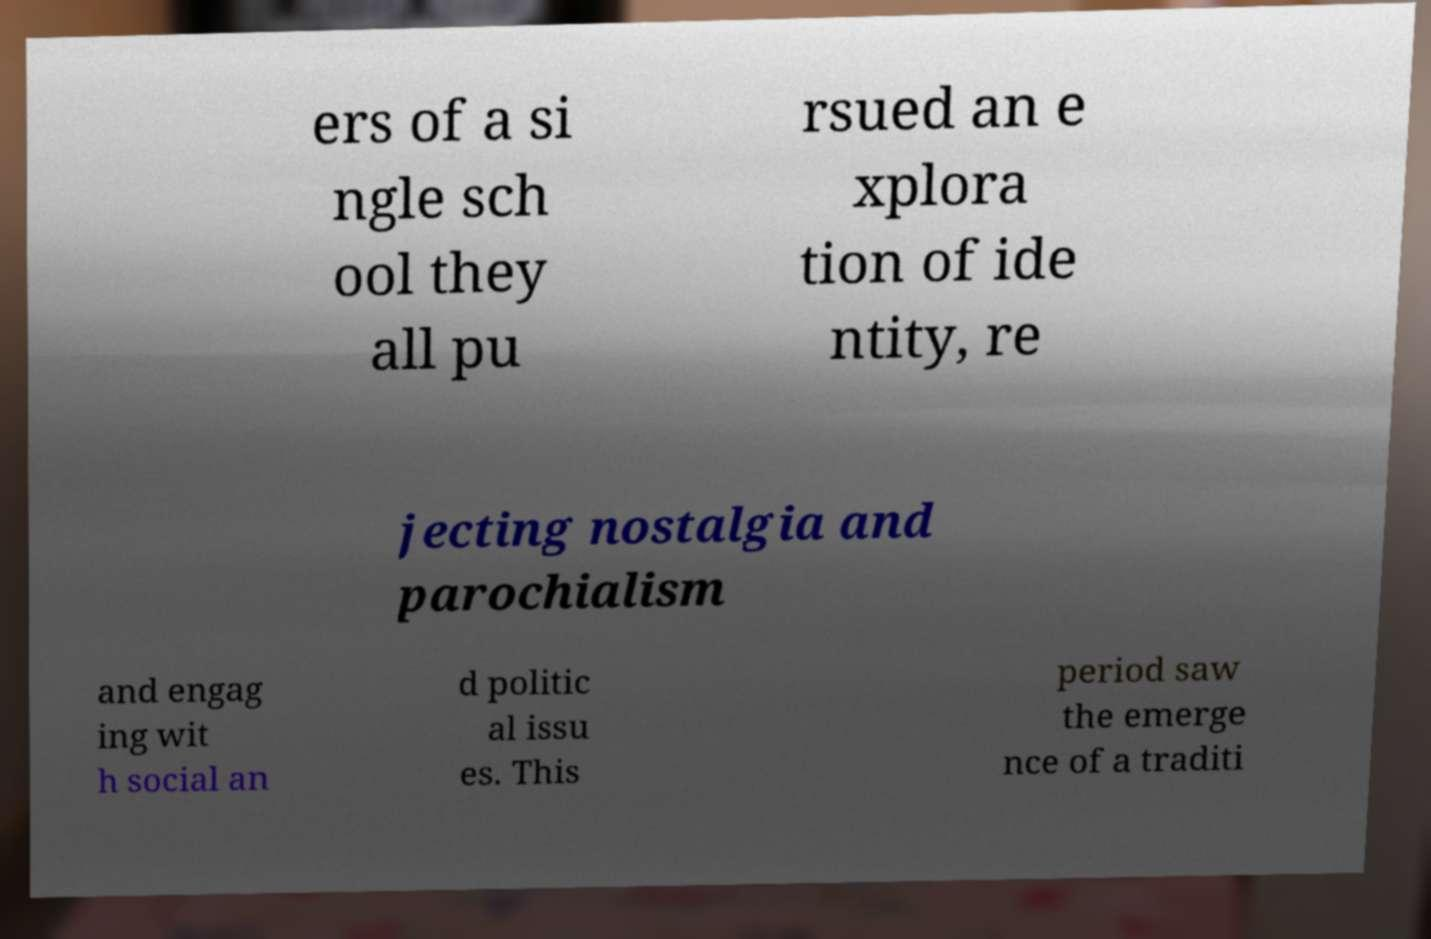What messages or text are displayed in this image? I need them in a readable, typed format. ers of a si ngle sch ool they all pu rsued an e xplora tion of ide ntity, re jecting nostalgia and parochialism and engag ing wit h social an d politic al issu es. This period saw the emerge nce of a traditi 